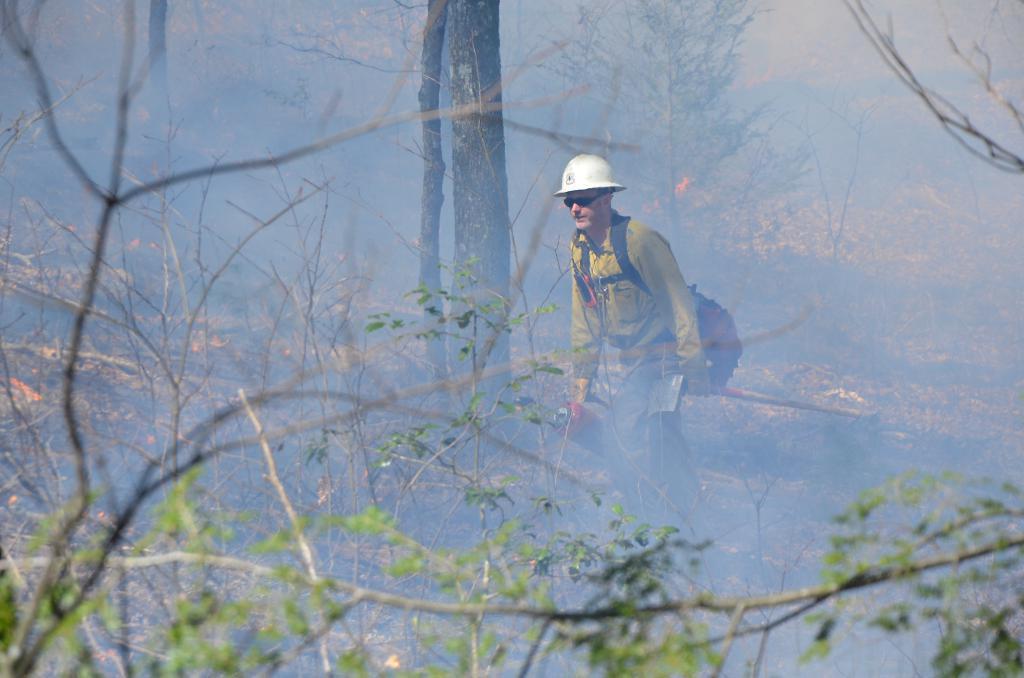How would you summarize this image in a sentence or two? In this image we can see a person, bag, trees, fire, smoke and other objects. 